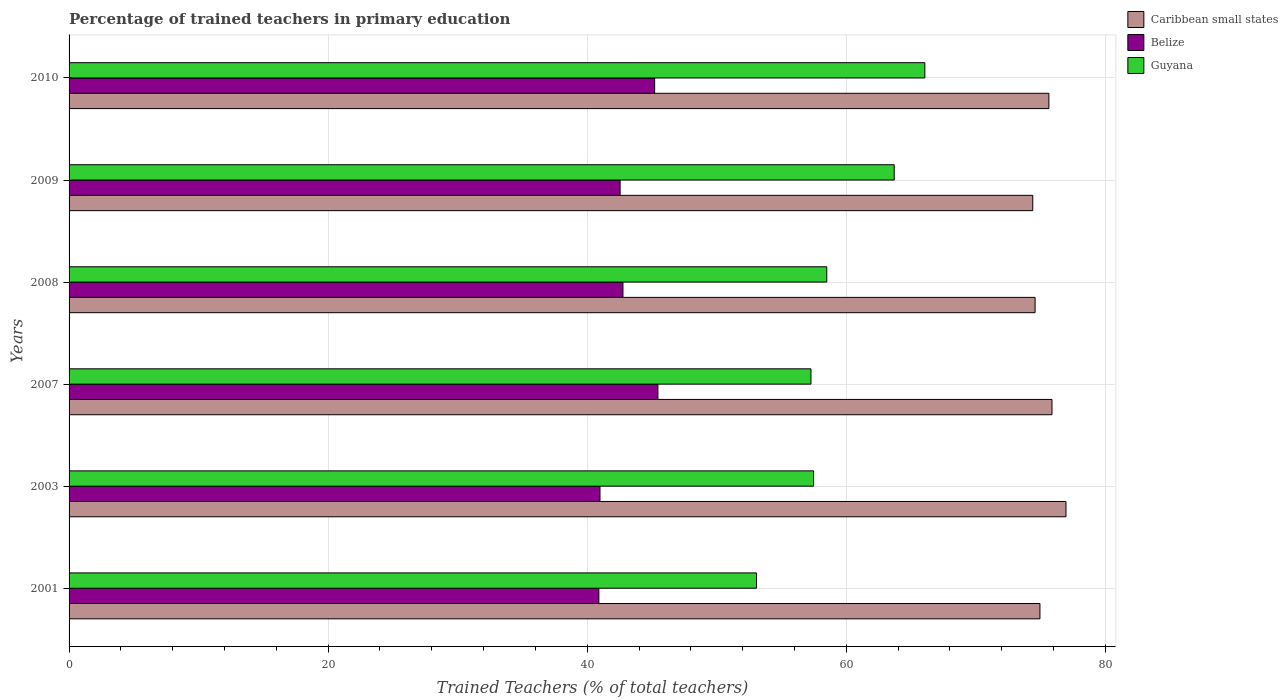How many different coloured bars are there?
Provide a short and direct response. 3. Are the number of bars on each tick of the Y-axis equal?
Offer a very short reply. Yes. How many bars are there on the 4th tick from the bottom?
Offer a very short reply. 3. What is the percentage of trained teachers in Guyana in 2010?
Give a very brief answer. 66.06. Across all years, what is the maximum percentage of trained teachers in Belize?
Your response must be concise. 45.46. Across all years, what is the minimum percentage of trained teachers in Guyana?
Provide a short and direct response. 53.07. In which year was the percentage of trained teachers in Belize minimum?
Give a very brief answer. 2001. What is the total percentage of trained teachers in Belize in the graph?
Ensure brevity in your answer.  257.84. What is the difference between the percentage of trained teachers in Guyana in 2007 and that in 2008?
Your answer should be very brief. -1.22. What is the difference between the percentage of trained teachers in Caribbean small states in 2010 and the percentage of trained teachers in Guyana in 2003?
Make the answer very short. 18.16. What is the average percentage of trained teachers in Belize per year?
Ensure brevity in your answer.  42.97. In the year 2010, what is the difference between the percentage of trained teachers in Caribbean small states and percentage of trained teachers in Belize?
Provide a succinct answer. 30.43. What is the ratio of the percentage of trained teachers in Guyana in 2007 to that in 2009?
Offer a terse response. 0.9. Is the percentage of trained teachers in Caribbean small states in 2007 less than that in 2009?
Keep it short and to the point. No. What is the difference between the highest and the second highest percentage of trained teachers in Belize?
Your response must be concise. 0.25. What is the difference between the highest and the lowest percentage of trained teachers in Belize?
Give a very brief answer. 4.56. In how many years, is the percentage of trained teachers in Guyana greater than the average percentage of trained teachers in Guyana taken over all years?
Your response must be concise. 2. What does the 1st bar from the top in 2008 represents?
Give a very brief answer. Guyana. What does the 2nd bar from the bottom in 2008 represents?
Offer a terse response. Belize. How many bars are there?
Offer a very short reply. 18. What is the difference between two consecutive major ticks on the X-axis?
Your response must be concise. 20. Does the graph contain any zero values?
Make the answer very short. No. Does the graph contain grids?
Offer a very short reply. Yes. Where does the legend appear in the graph?
Offer a very short reply. Top right. How many legend labels are there?
Give a very brief answer. 3. What is the title of the graph?
Your answer should be very brief. Percentage of trained teachers in primary education. What is the label or title of the X-axis?
Your response must be concise. Trained Teachers (% of total teachers). What is the label or title of the Y-axis?
Keep it short and to the point. Years. What is the Trained Teachers (% of total teachers) in Caribbean small states in 2001?
Ensure brevity in your answer.  74.95. What is the Trained Teachers (% of total teachers) of Belize in 2001?
Offer a terse response. 40.9. What is the Trained Teachers (% of total teachers) in Guyana in 2001?
Your answer should be very brief. 53.07. What is the Trained Teachers (% of total teachers) in Caribbean small states in 2003?
Your answer should be very brief. 76.96. What is the Trained Teachers (% of total teachers) in Belize in 2003?
Offer a terse response. 40.99. What is the Trained Teachers (% of total teachers) of Guyana in 2003?
Make the answer very short. 57.47. What is the Trained Teachers (% of total teachers) in Caribbean small states in 2007?
Your answer should be compact. 75.88. What is the Trained Teachers (% of total teachers) of Belize in 2007?
Give a very brief answer. 45.46. What is the Trained Teachers (% of total teachers) in Guyana in 2007?
Your answer should be compact. 57.27. What is the Trained Teachers (% of total teachers) in Caribbean small states in 2008?
Offer a terse response. 74.57. What is the Trained Teachers (% of total teachers) in Belize in 2008?
Ensure brevity in your answer.  42.76. What is the Trained Teachers (% of total teachers) of Guyana in 2008?
Provide a short and direct response. 58.49. What is the Trained Teachers (% of total teachers) in Caribbean small states in 2009?
Give a very brief answer. 74.39. What is the Trained Teachers (% of total teachers) in Belize in 2009?
Provide a succinct answer. 42.54. What is the Trained Teachers (% of total teachers) of Guyana in 2009?
Provide a short and direct response. 63.7. What is the Trained Teachers (% of total teachers) in Caribbean small states in 2010?
Give a very brief answer. 75.64. What is the Trained Teachers (% of total teachers) in Belize in 2010?
Keep it short and to the point. 45.2. What is the Trained Teachers (% of total teachers) of Guyana in 2010?
Keep it short and to the point. 66.06. Across all years, what is the maximum Trained Teachers (% of total teachers) of Caribbean small states?
Your response must be concise. 76.96. Across all years, what is the maximum Trained Teachers (% of total teachers) of Belize?
Make the answer very short. 45.46. Across all years, what is the maximum Trained Teachers (% of total teachers) in Guyana?
Your answer should be compact. 66.06. Across all years, what is the minimum Trained Teachers (% of total teachers) in Caribbean small states?
Your answer should be very brief. 74.39. Across all years, what is the minimum Trained Teachers (% of total teachers) of Belize?
Provide a succinct answer. 40.9. Across all years, what is the minimum Trained Teachers (% of total teachers) in Guyana?
Give a very brief answer. 53.07. What is the total Trained Teachers (% of total teachers) of Caribbean small states in the graph?
Ensure brevity in your answer.  452.39. What is the total Trained Teachers (% of total teachers) of Belize in the graph?
Ensure brevity in your answer.  257.84. What is the total Trained Teachers (% of total teachers) in Guyana in the graph?
Make the answer very short. 356.07. What is the difference between the Trained Teachers (% of total teachers) of Caribbean small states in 2001 and that in 2003?
Your response must be concise. -2.01. What is the difference between the Trained Teachers (% of total teachers) in Belize in 2001 and that in 2003?
Offer a terse response. -0.09. What is the difference between the Trained Teachers (% of total teachers) in Guyana in 2001 and that in 2003?
Give a very brief answer. -4.4. What is the difference between the Trained Teachers (% of total teachers) in Caribbean small states in 2001 and that in 2007?
Keep it short and to the point. -0.93. What is the difference between the Trained Teachers (% of total teachers) in Belize in 2001 and that in 2007?
Offer a terse response. -4.56. What is the difference between the Trained Teachers (% of total teachers) in Guyana in 2001 and that in 2007?
Ensure brevity in your answer.  -4.2. What is the difference between the Trained Teachers (% of total teachers) of Caribbean small states in 2001 and that in 2008?
Make the answer very short. 0.37. What is the difference between the Trained Teachers (% of total teachers) of Belize in 2001 and that in 2008?
Provide a succinct answer. -1.86. What is the difference between the Trained Teachers (% of total teachers) of Guyana in 2001 and that in 2008?
Your answer should be compact. -5.42. What is the difference between the Trained Teachers (% of total teachers) in Caribbean small states in 2001 and that in 2009?
Your answer should be compact. 0.55. What is the difference between the Trained Teachers (% of total teachers) in Belize in 2001 and that in 2009?
Give a very brief answer. -1.64. What is the difference between the Trained Teachers (% of total teachers) in Guyana in 2001 and that in 2009?
Ensure brevity in your answer.  -10.63. What is the difference between the Trained Teachers (% of total teachers) in Caribbean small states in 2001 and that in 2010?
Ensure brevity in your answer.  -0.69. What is the difference between the Trained Teachers (% of total teachers) in Belize in 2001 and that in 2010?
Your answer should be very brief. -4.31. What is the difference between the Trained Teachers (% of total teachers) in Guyana in 2001 and that in 2010?
Provide a short and direct response. -12.99. What is the difference between the Trained Teachers (% of total teachers) of Caribbean small states in 2003 and that in 2007?
Offer a terse response. 1.08. What is the difference between the Trained Teachers (% of total teachers) in Belize in 2003 and that in 2007?
Your answer should be very brief. -4.47. What is the difference between the Trained Teachers (% of total teachers) in Guyana in 2003 and that in 2007?
Ensure brevity in your answer.  0.2. What is the difference between the Trained Teachers (% of total teachers) in Caribbean small states in 2003 and that in 2008?
Your response must be concise. 2.38. What is the difference between the Trained Teachers (% of total teachers) in Belize in 2003 and that in 2008?
Offer a very short reply. -1.77. What is the difference between the Trained Teachers (% of total teachers) in Guyana in 2003 and that in 2008?
Ensure brevity in your answer.  -1.02. What is the difference between the Trained Teachers (% of total teachers) of Caribbean small states in 2003 and that in 2009?
Make the answer very short. 2.57. What is the difference between the Trained Teachers (% of total teachers) in Belize in 2003 and that in 2009?
Your answer should be compact. -1.55. What is the difference between the Trained Teachers (% of total teachers) of Guyana in 2003 and that in 2009?
Provide a short and direct response. -6.22. What is the difference between the Trained Teachers (% of total teachers) in Caribbean small states in 2003 and that in 2010?
Offer a very short reply. 1.32. What is the difference between the Trained Teachers (% of total teachers) in Belize in 2003 and that in 2010?
Give a very brief answer. -4.22. What is the difference between the Trained Teachers (% of total teachers) in Guyana in 2003 and that in 2010?
Your answer should be compact. -8.59. What is the difference between the Trained Teachers (% of total teachers) in Caribbean small states in 2007 and that in 2008?
Provide a succinct answer. 1.3. What is the difference between the Trained Teachers (% of total teachers) of Belize in 2007 and that in 2008?
Keep it short and to the point. 2.7. What is the difference between the Trained Teachers (% of total teachers) in Guyana in 2007 and that in 2008?
Provide a succinct answer. -1.22. What is the difference between the Trained Teachers (% of total teachers) of Caribbean small states in 2007 and that in 2009?
Give a very brief answer. 1.48. What is the difference between the Trained Teachers (% of total teachers) of Belize in 2007 and that in 2009?
Offer a terse response. 2.92. What is the difference between the Trained Teachers (% of total teachers) of Guyana in 2007 and that in 2009?
Your answer should be very brief. -6.43. What is the difference between the Trained Teachers (% of total teachers) of Caribbean small states in 2007 and that in 2010?
Keep it short and to the point. 0.24. What is the difference between the Trained Teachers (% of total teachers) in Belize in 2007 and that in 2010?
Offer a very short reply. 0.25. What is the difference between the Trained Teachers (% of total teachers) in Guyana in 2007 and that in 2010?
Offer a terse response. -8.79. What is the difference between the Trained Teachers (% of total teachers) of Caribbean small states in 2008 and that in 2009?
Provide a succinct answer. 0.18. What is the difference between the Trained Teachers (% of total teachers) in Belize in 2008 and that in 2009?
Give a very brief answer. 0.22. What is the difference between the Trained Teachers (% of total teachers) in Guyana in 2008 and that in 2009?
Offer a very short reply. -5.21. What is the difference between the Trained Teachers (% of total teachers) in Caribbean small states in 2008 and that in 2010?
Ensure brevity in your answer.  -1.06. What is the difference between the Trained Teachers (% of total teachers) in Belize in 2008 and that in 2010?
Ensure brevity in your answer.  -2.45. What is the difference between the Trained Teachers (% of total teachers) in Guyana in 2008 and that in 2010?
Keep it short and to the point. -7.57. What is the difference between the Trained Teachers (% of total teachers) of Caribbean small states in 2009 and that in 2010?
Your answer should be very brief. -1.25. What is the difference between the Trained Teachers (% of total teachers) of Belize in 2009 and that in 2010?
Your answer should be very brief. -2.67. What is the difference between the Trained Teachers (% of total teachers) of Guyana in 2009 and that in 2010?
Give a very brief answer. -2.36. What is the difference between the Trained Teachers (% of total teachers) of Caribbean small states in 2001 and the Trained Teachers (% of total teachers) of Belize in 2003?
Provide a succinct answer. 33.96. What is the difference between the Trained Teachers (% of total teachers) in Caribbean small states in 2001 and the Trained Teachers (% of total teachers) in Guyana in 2003?
Offer a very short reply. 17.47. What is the difference between the Trained Teachers (% of total teachers) in Belize in 2001 and the Trained Teachers (% of total teachers) in Guyana in 2003?
Offer a terse response. -16.58. What is the difference between the Trained Teachers (% of total teachers) in Caribbean small states in 2001 and the Trained Teachers (% of total teachers) in Belize in 2007?
Your response must be concise. 29.49. What is the difference between the Trained Teachers (% of total teachers) of Caribbean small states in 2001 and the Trained Teachers (% of total teachers) of Guyana in 2007?
Give a very brief answer. 17.68. What is the difference between the Trained Teachers (% of total teachers) of Belize in 2001 and the Trained Teachers (% of total teachers) of Guyana in 2007?
Your answer should be compact. -16.38. What is the difference between the Trained Teachers (% of total teachers) in Caribbean small states in 2001 and the Trained Teachers (% of total teachers) in Belize in 2008?
Make the answer very short. 32.19. What is the difference between the Trained Teachers (% of total teachers) in Caribbean small states in 2001 and the Trained Teachers (% of total teachers) in Guyana in 2008?
Your answer should be compact. 16.46. What is the difference between the Trained Teachers (% of total teachers) of Belize in 2001 and the Trained Teachers (% of total teachers) of Guyana in 2008?
Your answer should be very brief. -17.59. What is the difference between the Trained Teachers (% of total teachers) in Caribbean small states in 2001 and the Trained Teachers (% of total teachers) in Belize in 2009?
Your response must be concise. 32.41. What is the difference between the Trained Teachers (% of total teachers) of Caribbean small states in 2001 and the Trained Teachers (% of total teachers) of Guyana in 2009?
Offer a terse response. 11.25. What is the difference between the Trained Teachers (% of total teachers) of Belize in 2001 and the Trained Teachers (% of total teachers) of Guyana in 2009?
Keep it short and to the point. -22.8. What is the difference between the Trained Teachers (% of total teachers) in Caribbean small states in 2001 and the Trained Teachers (% of total teachers) in Belize in 2010?
Keep it short and to the point. 29.74. What is the difference between the Trained Teachers (% of total teachers) of Caribbean small states in 2001 and the Trained Teachers (% of total teachers) of Guyana in 2010?
Keep it short and to the point. 8.88. What is the difference between the Trained Teachers (% of total teachers) of Belize in 2001 and the Trained Teachers (% of total teachers) of Guyana in 2010?
Your answer should be compact. -25.17. What is the difference between the Trained Teachers (% of total teachers) in Caribbean small states in 2003 and the Trained Teachers (% of total teachers) in Belize in 2007?
Your answer should be compact. 31.5. What is the difference between the Trained Teachers (% of total teachers) in Caribbean small states in 2003 and the Trained Teachers (% of total teachers) in Guyana in 2007?
Give a very brief answer. 19.69. What is the difference between the Trained Teachers (% of total teachers) in Belize in 2003 and the Trained Teachers (% of total teachers) in Guyana in 2007?
Provide a short and direct response. -16.29. What is the difference between the Trained Teachers (% of total teachers) in Caribbean small states in 2003 and the Trained Teachers (% of total teachers) in Belize in 2008?
Offer a terse response. 34.2. What is the difference between the Trained Teachers (% of total teachers) of Caribbean small states in 2003 and the Trained Teachers (% of total teachers) of Guyana in 2008?
Make the answer very short. 18.47. What is the difference between the Trained Teachers (% of total teachers) in Belize in 2003 and the Trained Teachers (% of total teachers) in Guyana in 2008?
Keep it short and to the point. -17.51. What is the difference between the Trained Teachers (% of total teachers) of Caribbean small states in 2003 and the Trained Teachers (% of total teachers) of Belize in 2009?
Ensure brevity in your answer.  34.42. What is the difference between the Trained Teachers (% of total teachers) in Caribbean small states in 2003 and the Trained Teachers (% of total teachers) in Guyana in 2009?
Offer a terse response. 13.26. What is the difference between the Trained Teachers (% of total teachers) in Belize in 2003 and the Trained Teachers (% of total teachers) in Guyana in 2009?
Your answer should be very brief. -22.71. What is the difference between the Trained Teachers (% of total teachers) in Caribbean small states in 2003 and the Trained Teachers (% of total teachers) in Belize in 2010?
Provide a short and direct response. 31.75. What is the difference between the Trained Teachers (% of total teachers) of Caribbean small states in 2003 and the Trained Teachers (% of total teachers) of Guyana in 2010?
Ensure brevity in your answer.  10.9. What is the difference between the Trained Teachers (% of total teachers) of Belize in 2003 and the Trained Teachers (% of total teachers) of Guyana in 2010?
Provide a succinct answer. -25.08. What is the difference between the Trained Teachers (% of total teachers) of Caribbean small states in 2007 and the Trained Teachers (% of total teachers) of Belize in 2008?
Ensure brevity in your answer.  33.12. What is the difference between the Trained Teachers (% of total teachers) of Caribbean small states in 2007 and the Trained Teachers (% of total teachers) of Guyana in 2008?
Make the answer very short. 17.39. What is the difference between the Trained Teachers (% of total teachers) in Belize in 2007 and the Trained Teachers (% of total teachers) in Guyana in 2008?
Your answer should be very brief. -13.03. What is the difference between the Trained Teachers (% of total teachers) in Caribbean small states in 2007 and the Trained Teachers (% of total teachers) in Belize in 2009?
Offer a very short reply. 33.34. What is the difference between the Trained Teachers (% of total teachers) of Caribbean small states in 2007 and the Trained Teachers (% of total teachers) of Guyana in 2009?
Provide a short and direct response. 12.18. What is the difference between the Trained Teachers (% of total teachers) in Belize in 2007 and the Trained Teachers (% of total teachers) in Guyana in 2009?
Provide a short and direct response. -18.24. What is the difference between the Trained Teachers (% of total teachers) of Caribbean small states in 2007 and the Trained Teachers (% of total teachers) of Belize in 2010?
Your answer should be very brief. 30.67. What is the difference between the Trained Teachers (% of total teachers) of Caribbean small states in 2007 and the Trained Teachers (% of total teachers) of Guyana in 2010?
Keep it short and to the point. 9.82. What is the difference between the Trained Teachers (% of total teachers) of Belize in 2007 and the Trained Teachers (% of total teachers) of Guyana in 2010?
Your response must be concise. -20.6. What is the difference between the Trained Teachers (% of total teachers) in Caribbean small states in 2008 and the Trained Teachers (% of total teachers) in Belize in 2009?
Offer a very short reply. 32.04. What is the difference between the Trained Teachers (% of total teachers) of Caribbean small states in 2008 and the Trained Teachers (% of total teachers) of Guyana in 2009?
Provide a short and direct response. 10.88. What is the difference between the Trained Teachers (% of total teachers) of Belize in 2008 and the Trained Teachers (% of total teachers) of Guyana in 2009?
Give a very brief answer. -20.94. What is the difference between the Trained Teachers (% of total teachers) of Caribbean small states in 2008 and the Trained Teachers (% of total teachers) of Belize in 2010?
Provide a short and direct response. 29.37. What is the difference between the Trained Teachers (% of total teachers) of Caribbean small states in 2008 and the Trained Teachers (% of total teachers) of Guyana in 2010?
Keep it short and to the point. 8.51. What is the difference between the Trained Teachers (% of total teachers) of Belize in 2008 and the Trained Teachers (% of total teachers) of Guyana in 2010?
Your response must be concise. -23.31. What is the difference between the Trained Teachers (% of total teachers) in Caribbean small states in 2009 and the Trained Teachers (% of total teachers) in Belize in 2010?
Your answer should be compact. 29.19. What is the difference between the Trained Teachers (% of total teachers) in Caribbean small states in 2009 and the Trained Teachers (% of total teachers) in Guyana in 2010?
Provide a short and direct response. 8.33. What is the difference between the Trained Teachers (% of total teachers) in Belize in 2009 and the Trained Teachers (% of total teachers) in Guyana in 2010?
Your response must be concise. -23.53. What is the average Trained Teachers (% of total teachers) of Caribbean small states per year?
Provide a short and direct response. 75.4. What is the average Trained Teachers (% of total teachers) in Belize per year?
Your answer should be very brief. 42.97. What is the average Trained Teachers (% of total teachers) of Guyana per year?
Your answer should be very brief. 59.35. In the year 2001, what is the difference between the Trained Teachers (% of total teachers) of Caribbean small states and Trained Teachers (% of total teachers) of Belize?
Your response must be concise. 34.05. In the year 2001, what is the difference between the Trained Teachers (% of total teachers) of Caribbean small states and Trained Teachers (% of total teachers) of Guyana?
Offer a very short reply. 21.88. In the year 2001, what is the difference between the Trained Teachers (% of total teachers) in Belize and Trained Teachers (% of total teachers) in Guyana?
Give a very brief answer. -12.17. In the year 2003, what is the difference between the Trained Teachers (% of total teachers) in Caribbean small states and Trained Teachers (% of total teachers) in Belize?
Provide a short and direct response. 35.97. In the year 2003, what is the difference between the Trained Teachers (% of total teachers) of Caribbean small states and Trained Teachers (% of total teachers) of Guyana?
Offer a terse response. 19.48. In the year 2003, what is the difference between the Trained Teachers (% of total teachers) of Belize and Trained Teachers (% of total teachers) of Guyana?
Provide a short and direct response. -16.49. In the year 2007, what is the difference between the Trained Teachers (% of total teachers) of Caribbean small states and Trained Teachers (% of total teachers) of Belize?
Give a very brief answer. 30.42. In the year 2007, what is the difference between the Trained Teachers (% of total teachers) of Caribbean small states and Trained Teachers (% of total teachers) of Guyana?
Offer a terse response. 18.61. In the year 2007, what is the difference between the Trained Teachers (% of total teachers) in Belize and Trained Teachers (% of total teachers) in Guyana?
Provide a succinct answer. -11.81. In the year 2008, what is the difference between the Trained Teachers (% of total teachers) of Caribbean small states and Trained Teachers (% of total teachers) of Belize?
Ensure brevity in your answer.  31.82. In the year 2008, what is the difference between the Trained Teachers (% of total teachers) in Caribbean small states and Trained Teachers (% of total teachers) in Guyana?
Your answer should be very brief. 16.08. In the year 2008, what is the difference between the Trained Teachers (% of total teachers) of Belize and Trained Teachers (% of total teachers) of Guyana?
Your response must be concise. -15.73. In the year 2009, what is the difference between the Trained Teachers (% of total teachers) in Caribbean small states and Trained Teachers (% of total teachers) in Belize?
Your answer should be very brief. 31.86. In the year 2009, what is the difference between the Trained Teachers (% of total teachers) of Caribbean small states and Trained Teachers (% of total teachers) of Guyana?
Provide a short and direct response. 10.69. In the year 2009, what is the difference between the Trained Teachers (% of total teachers) of Belize and Trained Teachers (% of total teachers) of Guyana?
Keep it short and to the point. -21.16. In the year 2010, what is the difference between the Trained Teachers (% of total teachers) in Caribbean small states and Trained Teachers (% of total teachers) in Belize?
Ensure brevity in your answer.  30.43. In the year 2010, what is the difference between the Trained Teachers (% of total teachers) in Caribbean small states and Trained Teachers (% of total teachers) in Guyana?
Offer a terse response. 9.58. In the year 2010, what is the difference between the Trained Teachers (% of total teachers) in Belize and Trained Teachers (% of total teachers) in Guyana?
Your answer should be compact. -20.86. What is the ratio of the Trained Teachers (% of total teachers) of Caribbean small states in 2001 to that in 2003?
Ensure brevity in your answer.  0.97. What is the ratio of the Trained Teachers (% of total teachers) of Guyana in 2001 to that in 2003?
Keep it short and to the point. 0.92. What is the ratio of the Trained Teachers (% of total teachers) of Belize in 2001 to that in 2007?
Your answer should be compact. 0.9. What is the ratio of the Trained Teachers (% of total teachers) of Guyana in 2001 to that in 2007?
Offer a very short reply. 0.93. What is the ratio of the Trained Teachers (% of total teachers) in Caribbean small states in 2001 to that in 2008?
Your answer should be compact. 1. What is the ratio of the Trained Teachers (% of total teachers) of Belize in 2001 to that in 2008?
Make the answer very short. 0.96. What is the ratio of the Trained Teachers (% of total teachers) in Guyana in 2001 to that in 2008?
Provide a succinct answer. 0.91. What is the ratio of the Trained Teachers (% of total teachers) of Caribbean small states in 2001 to that in 2009?
Your response must be concise. 1.01. What is the ratio of the Trained Teachers (% of total teachers) in Belize in 2001 to that in 2009?
Offer a terse response. 0.96. What is the ratio of the Trained Teachers (% of total teachers) of Guyana in 2001 to that in 2009?
Ensure brevity in your answer.  0.83. What is the ratio of the Trained Teachers (% of total teachers) in Caribbean small states in 2001 to that in 2010?
Offer a terse response. 0.99. What is the ratio of the Trained Teachers (% of total teachers) in Belize in 2001 to that in 2010?
Your answer should be compact. 0.9. What is the ratio of the Trained Teachers (% of total teachers) in Guyana in 2001 to that in 2010?
Give a very brief answer. 0.8. What is the ratio of the Trained Teachers (% of total teachers) of Caribbean small states in 2003 to that in 2007?
Offer a terse response. 1.01. What is the ratio of the Trained Teachers (% of total teachers) in Belize in 2003 to that in 2007?
Provide a short and direct response. 0.9. What is the ratio of the Trained Teachers (% of total teachers) in Guyana in 2003 to that in 2007?
Your answer should be compact. 1. What is the ratio of the Trained Teachers (% of total teachers) of Caribbean small states in 2003 to that in 2008?
Offer a very short reply. 1.03. What is the ratio of the Trained Teachers (% of total teachers) in Belize in 2003 to that in 2008?
Ensure brevity in your answer.  0.96. What is the ratio of the Trained Teachers (% of total teachers) in Guyana in 2003 to that in 2008?
Make the answer very short. 0.98. What is the ratio of the Trained Teachers (% of total teachers) in Caribbean small states in 2003 to that in 2009?
Give a very brief answer. 1.03. What is the ratio of the Trained Teachers (% of total teachers) in Belize in 2003 to that in 2009?
Provide a short and direct response. 0.96. What is the ratio of the Trained Teachers (% of total teachers) of Guyana in 2003 to that in 2009?
Your answer should be compact. 0.9. What is the ratio of the Trained Teachers (% of total teachers) of Caribbean small states in 2003 to that in 2010?
Ensure brevity in your answer.  1.02. What is the ratio of the Trained Teachers (% of total teachers) in Belize in 2003 to that in 2010?
Ensure brevity in your answer.  0.91. What is the ratio of the Trained Teachers (% of total teachers) in Guyana in 2003 to that in 2010?
Provide a short and direct response. 0.87. What is the ratio of the Trained Teachers (% of total teachers) in Caribbean small states in 2007 to that in 2008?
Your answer should be compact. 1.02. What is the ratio of the Trained Teachers (% of total teachers) in Belize in 2007 to that in 2008?
Your answer should be very brief. 1.06. What is the ratio of the Trained Teachers (% of total teachers) in Guyana in 2007 to that in 2008?
Ensure brevity in your answer.  0.98. What is the ratio of the Trained Teachers (% of total teachers) in Belize in 2007 to that in 2009?
Your answer should be very brief. 1.07. What is the ratio of the Trained Teachers (% of total teachers) in Guyana in 2007 to that in 2009?
Offer a very short reply. 0.9. What is the ratio of the Trained Teachers (% of total teachers) in Belize in 2007 to that in 2010?
Your answer should be compact. 1.01. What is the ratio of the Trained Teachers (% of total teachers) in Guyana in 2007 to that in 2010?
Your response must be concise. 0.87. What is the ratio of the Trained Teachers (% of total teachers) in Caribbean small states in 2008 to that in 2009?
Provide a succinct answer. 1. What is the ratio of the Trained Teachers (% of total teachers) in Belize in 2008 to that in 2009?
Make the answer very short. 1.01. What is the ratio of the Trained Teachers (% of total teachers) in Guyana in 2008 to that in 2009?
Make the answer very short. 0.92. What is the ratio of the Trained Teachers (% of total teachers) of Caribbean small states in 2008 to that in 2010?
Keep it short and to the point. 0.99. What is the ratio of the Trained Teachers (% of total teachers) in Belize in 2008 to that in 2010?
Provide a short and direct response. 0.95. What is the ratio of the Trained Teachers (% of total teachers) in Guyana in 2008 to that in 2010?
Your answer should be compact. 0.89. What is the ratio of the Trained Teachers (% of total teachers) of Caribbean small states in 2009 to that in 2010?
Offer a terse response. 0.98. What is the ratio of the Trained Teachers (% of total teachers) in Belize in 2009 to that in 2010?
Offer a terse response. 0.94. What is the ratio of the Trained Teachers (% of total teachers) of Guyana in 2009 to that in 2010?
Your response must be concise. 0.96. What is the difference between the highest and the second highest Trained Teachers (% of total teachers) in Caribbean small states?
Make the answer very short. 1.08. What is the difference between the highest and the second highest Trained Teachers (% of total teachers) of Belize?
Offer a terse response. 0.25. What is the difference between the highest and the second highest Trained Teachers (% of total teachers) of Guyana?
Give a very brief answer. 2.36. What is the difference between the highest and the lowest Trained Teachers (% of total teachers) of Caribbean small states?
Provide a succinct answer. 2.57. What is the difference between the highest and the lowest Trained Teachers (% of total teachers) of Belize?
Your response must be concise. 4.56. What is the difference between the highest and the lowest Trained Teachers (% of total teachers) in Guyana?
Your response must be concise. 12.99. 